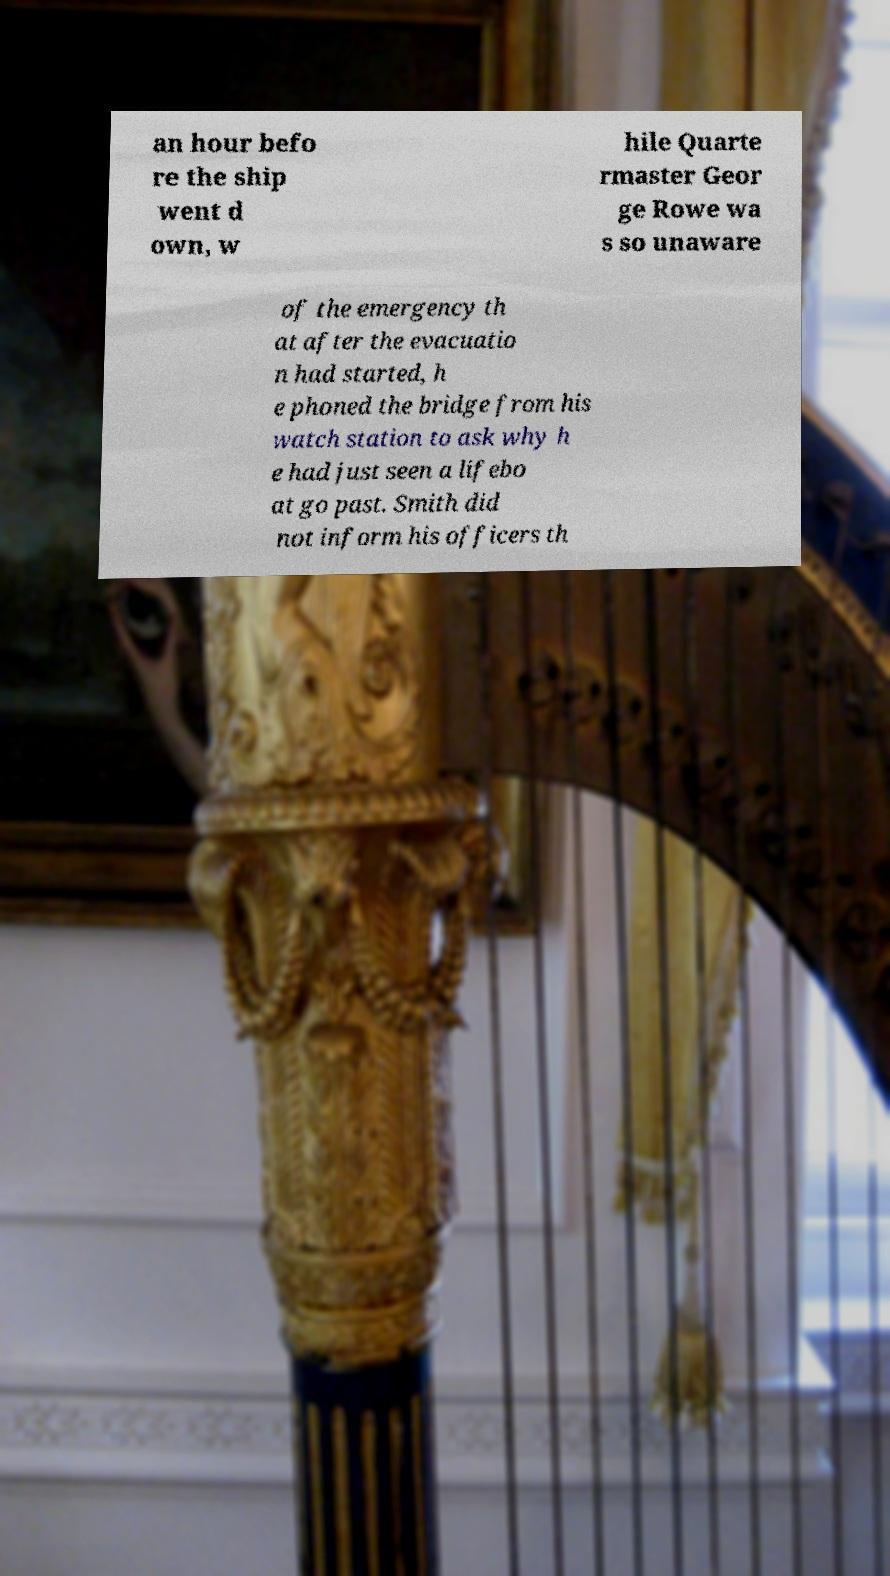I need the written content from this picture converted into text. Can you do that? an hour befo re the ship went d own, w hile Quarte rmaster Geor ge Rowe wa s so unaware of the emergency th at after the evacuatio n had started, h e phoned the bridge from his watch station to ask why h e had just seen a lifebo at go past. Smith did not inform his officers th 